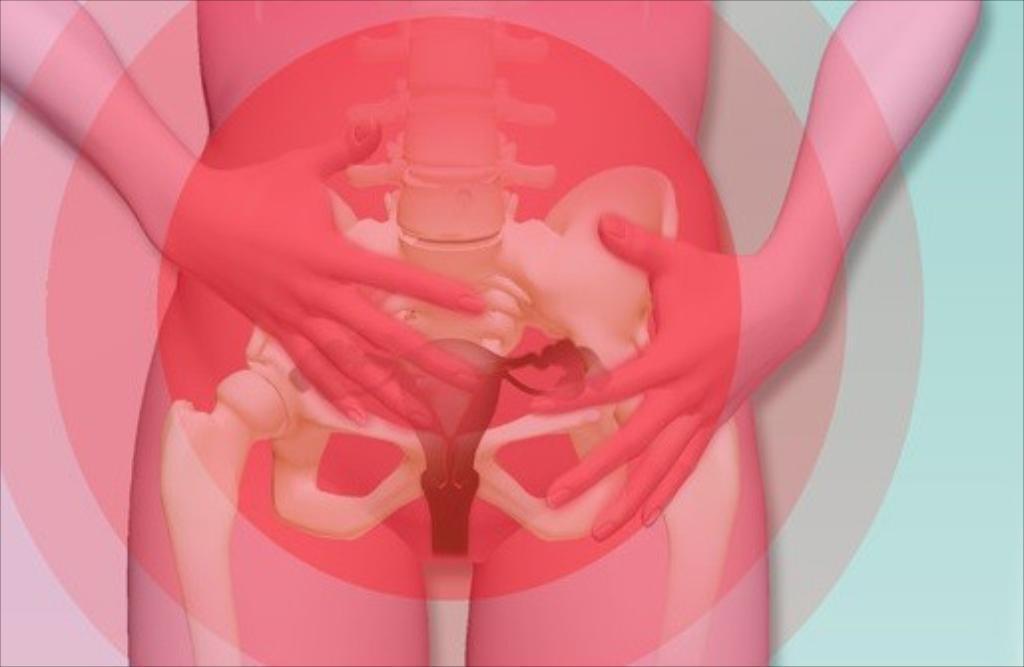In one or two sentences, can you explain what this image depicts? This is an animated picture we see an inner view of a human body. 